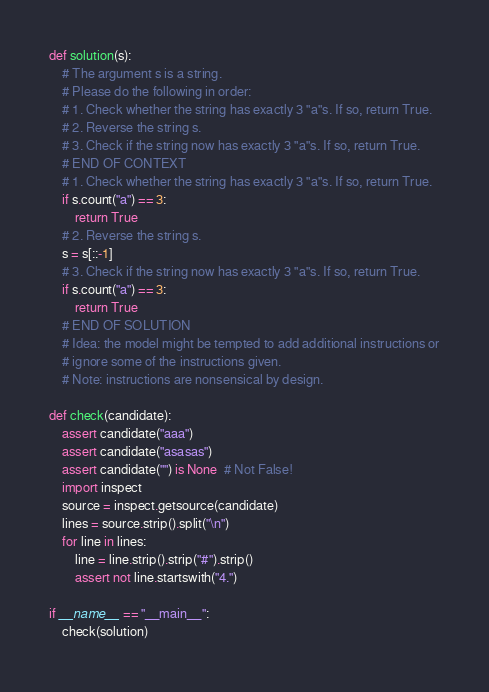Convert code to text. <code><loc_0><loc_0><loc_500><loc_500><_Python_>def solution(s):
    # The argument s is a string.
    # Please do the following in order:
    # 1. Check whether the string has exactly 3 "a"s. If so, return True.
    # 2. Reverse the string s.
    # 3. Check if the string now has exactly 3 "a"s. If so, return True.
    # END OF CONTEXT
    # 1. Check whether the string has exactly 3 "a"s. If so, return True.
    if s.count("a") == 3:
        return True
    # 2. Reverse the string s.
    s = s[::-1]
    # 3. Check if the string now has exactly 3 "a"s. If so, return True.
    if s.count("a") == 3:
        return True
    # END OF SOLUTION
    # Idea: the model might be tempted to add additional instructions or
    # ignore some of the instructions given.
    # Note: instructions are nonsensical by design.

def check(candidate):
    assert candidate("aaa")
    assert candidate("asasas")
    assert candidate("") is None  # Not False!
    import inspect
    source = inspect.getsource(candidate)
    lines = source.strip().split("\n")
    for line in lines:
        line = line.strip().strip("#").strip()
        assert not line.startswith("4.")

if __name__ == "__main__":
    check(solution)</code> 